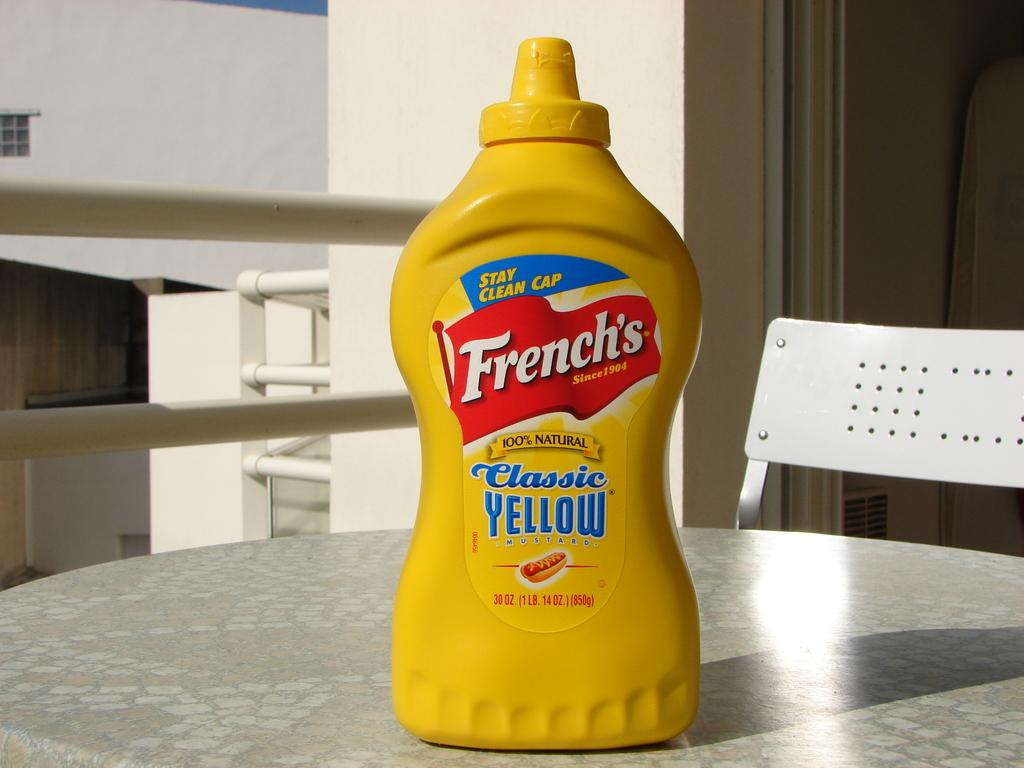<image>
Create a compact narrative representing the image presented. Frenches yellow mustard sitting on a table on a balcony 